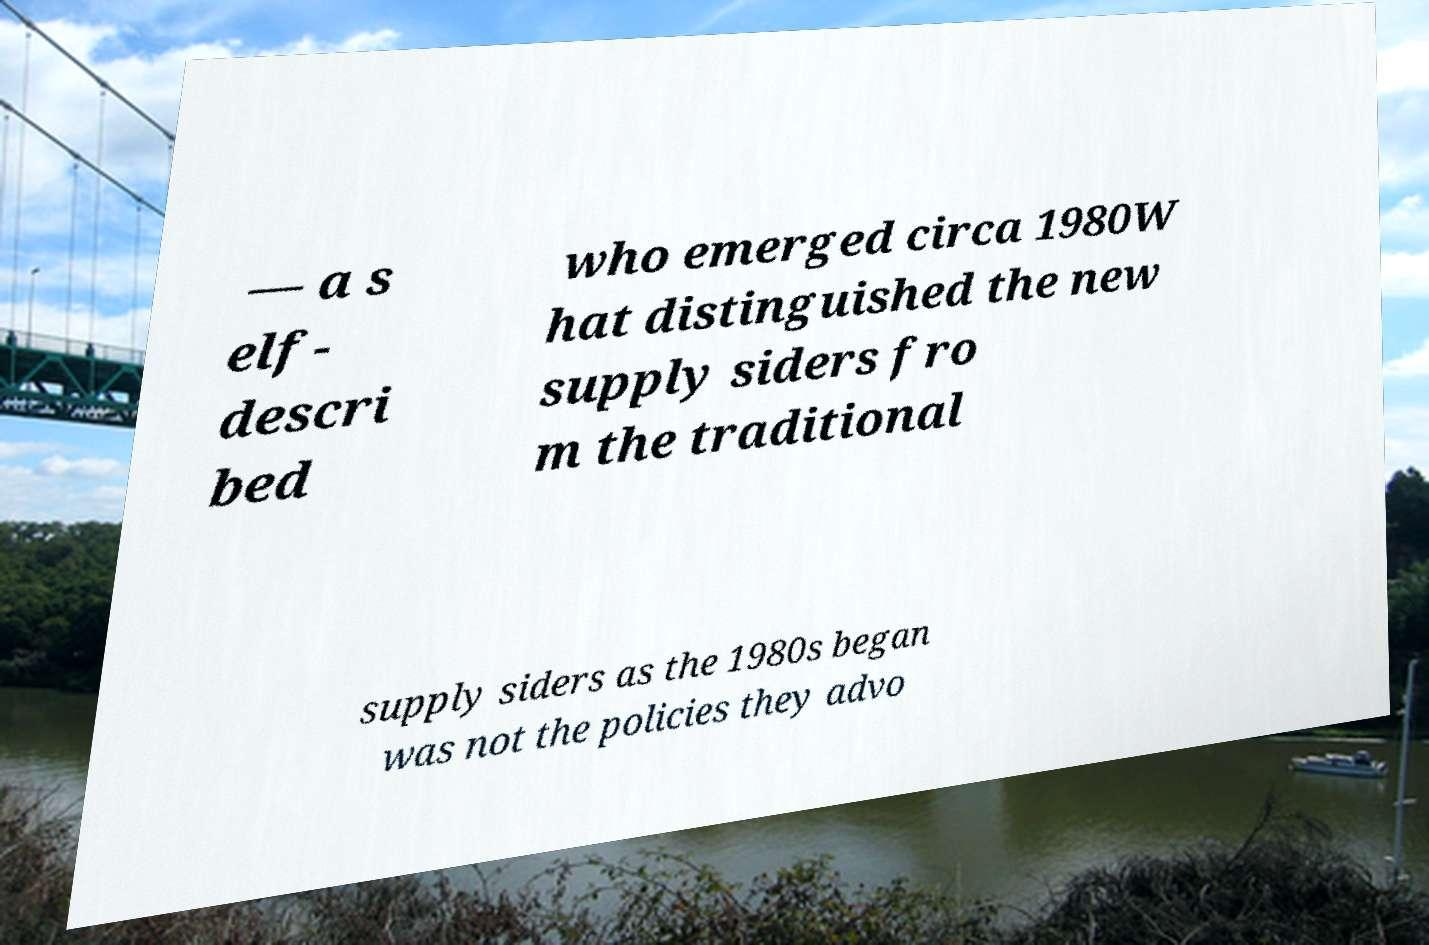Please identify and transcribe the text found in this image. — a s elf- descri bed who emerged circa 1980W hat distinguished the new supply siders fro m the traditional supply siders as the 1980s began was not the policies they advo 